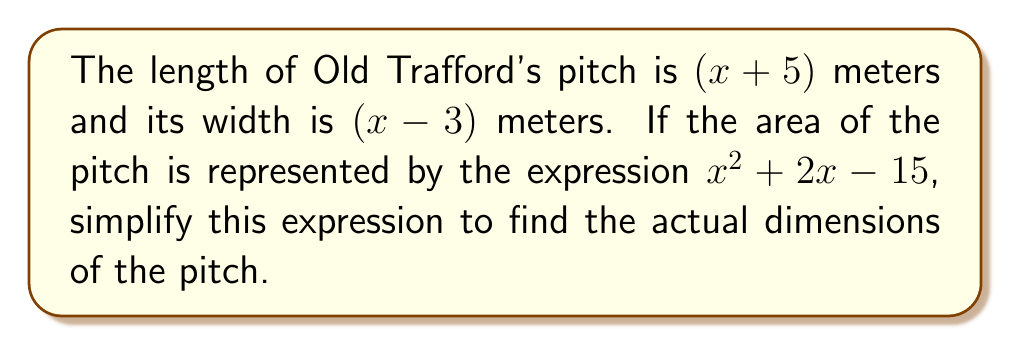Can you solve this math problem? Let's approach this step-by-step:

1) The area of a rectangle is given by length × width. So we can set up the equation:

   $(x+5)(x-3) = x^2 + 2x - 15$

2) Let's expand the left side of the equation:
   
   $(x+5)(x-3) = x^2 - 3x + 5x - 15 = x^2 + 2x - 15$

3) We can see that the expanded form matches the given expression exactly. This means our equation is correct.

4) To find the actual dimensions, we need to solve for $x$. However, we don't have enough information to do this.

5) Instead, we can express the dimensions in terms of $x$:

   Length: $x + 5$ meters
   Width: $x - 3$ meters

6) These expressions are already in their simplest form.

Therefore, the simplified expressions for the dimensions of Old Trafford's pitch are $x + 5$ meters for length and $x - 3$ meters for width.
Answer: Length: $x + 5$ m, Width: $x - 3$ m 